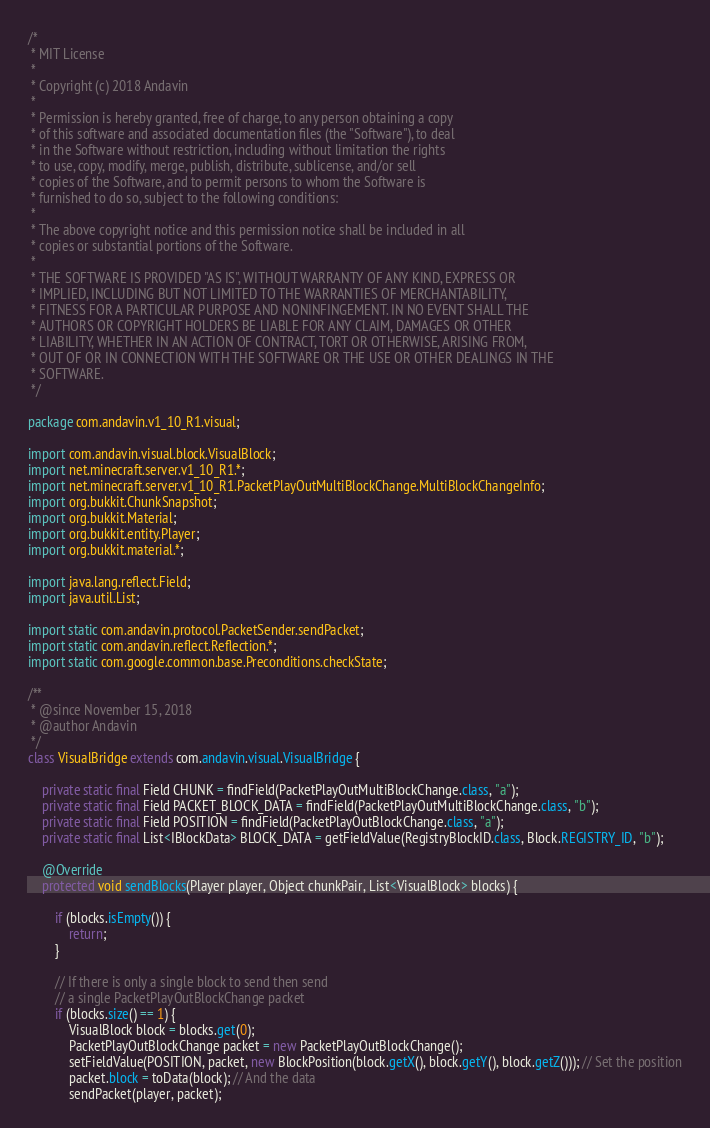<code> <loc_0><loc_0><loc_500><loc_500><_Java_>/*
 * MIT License
 *
 * Copyright (c) 2018 Andavin
 *
 * Permission is hereby granted, free of charge, to any person obtaining a copy
 * of this software and associated documentation files (the "Software"), to deal
 * in the Software without restriction, including without limitation the rights
 * to use, copy, modify, merge, publish, distribute, sublicense, and/or sell
 * copies of the Software, and to permit persons to whom the Software is
 * furnished to do so, subject to the following conditions:
 *
 * The above copyright notice and this permission notice shall be included in all
 * copies or substantial portions of the Software.
 *
 * THE SOFTWARE IS PROVIDED "AS IS", WITHOUT WARRANTY OF ANY KIND, EXPRESS OR
 * IMPLIED, INCLUDING BUT NOT LIMITED TO THE WARRANTIES OF MERCHANTABILITY,
 * FITNESS FOR A PARTICULAR PURPOSE AND NONINFINGEMENT. IN NO EVENT SHALL THE
 * AUTHORS OR COPYRIGHT HOLDERS BE LIABLE FOR ANY CLAIM, DAMAGES OR OTHER
 * LIABILITY, WHETHER IN AN ACTION OF CONTRACT, TORT OR OTHERWISE, ARISING FROM,
 * OUT OF OR IN CONNECTION WITH THE SOFTWARE OR THE USE OR OTHER DEALINGS IN THE
 * SOFTWARE.
 */

package com.andavin.v1_10_R1.visual;

import com.andavin.visual.block.VisualBlock;
import net.minecraft.server.v1_10_R1.*;
import net.minecraft.server.v1_10_R1.PacketPlayOutMultiBlockChange.MultiBlockChangeInfo;
import org.bukkit.ChunkSnapshot;
import org.bukkit.Material;
import org.bukkit.entity.Player;
import org.bukkit.material.*;

import java.lang.reflect.Field;
import java.util.List;

import static com.andavin.protocol.PacketSender.sendPacket;
import static com.andavin.reflect.Reflection.*;
import static com.google.common.base.Preconditions.checkState;

/**
 * @since November 15, 2018
 * @author Andavin
 */
class VisualBridge extends com.andavin.visual.VisualBridge {

    private static final Field CHUNK = findField(PacketPlayOutMultiBlockChange.class, "a");
    private static final Field PACKET_BLOCK_DATA = findField(PacketPlayOutMultiBlockChange.class, "b");
    private static final Field POSITION = findField(PacketPlayOutBlockChange.class, "a");
    private static final List<IBlockData> BLOCK_DATA = getFieldValue(RegistryBlockID.class, Block.REGISTRY_ID, "b");

    @Override
    protected void sendBlocks(Player player, Object chunkPair, List<VisualBlock> blocks) {

        if (blocks.isEmpty()) {
            return;
        }

        // If there is only a single block to send then send
        // a single PacketPlayOutBlockChange packet
        if (blocks.size() == 1) {
            VisualBlock block = blocks.get(0);
            PacketPlayOutBlockChange packet = new PacketPlayOutBlockChange();
            setFieldValue(POSITION, packet, new BlockPosition(block.getX(), block.getY(), block.getZ())); // Set the position
            packet.block = toData(block); // And the data
            sendPacket(player, packet);</code> 